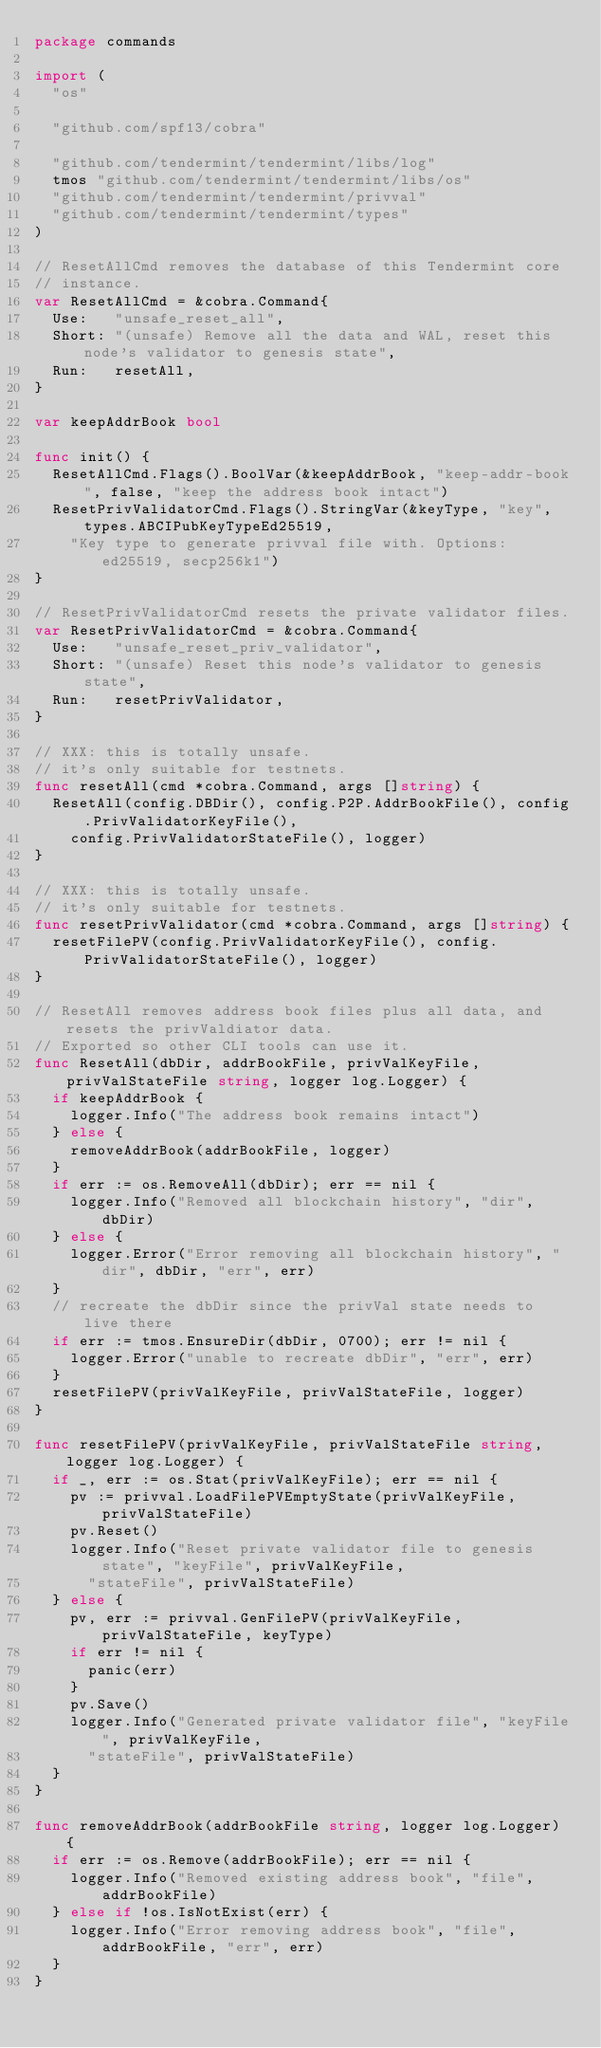Convert code to text. <code><loc_0><loc_0><loc_500><loc_500><_Go_>package commands

import (
	"os"

	"github.com/spf13/cobra"

	"github.com/tendermint/tendermint/libs/log"
	tmos "github.com/tendermint/tendermint/libs/os"
	"github.com/tendermint/tendermint/privval"
	"github.com/tendermint/tendermint/types"
)

// ResetAllCmd removes the database of this Tendermint core
// instance.
var ResetAllCmd = &cobra.Command{
	Use:   "unsafe_reset_all",
	Short: "(unsafe) Remove all the data and WAL, reset this node's validator to genesis state",
	Run:   resetAll,
}

var keepAddrBook bool

func init() {
	ResetAllCmd.Flags().BoolVar(&keepAddrBook, "keep-addr-book", false, "keep the address book intact")
	ResetPrivValidatorCmd.Flags().StringVar(&keyType, "key", types.ABCIPubKeyTypeEd25519,
		"Key type to generate privval file with. Options: ed25519, secp256k1")
}

// ResetPrivValidatorCmd resets the private validator files.
var ResetPrivValidatorCmd = &cobra.Command{
	Use:   "unsafe_reset_priv_validator",
	Short: "(unsafe) Reset this node's validator to genesis state",
	Run:   resetPrivValidator,
}

// XXX: this is totally unsafe.
// it's only suitable for testnets.
func resetAll(cmd *cobra.Command, args []string) {
	ResetAll(config.DBDir(), config.P2P.AddrBookFile(), config.PrivValidatorKeyFile(),
		config.PrivValidatorStateFile(), logger)
}

// XXX: this is totally unsafe.
// it's only suitable for testnets.
func resetPrivValidator(cmd *cobra.Command, args []string) {
	resetFilePV(config.PrivValidatorKeyFile(), config.PrivValidatorStateFile(), logger)
}

// ResetAll removes address book files plus all data, and resets the privValdiator data.
// Exported so other CLI tools can use it.
func ResetAll(dbDir, addrBookFile, privValKeyFile, privValStateFile string, logger log.Logger) {
	if keepAddrBook {
		logger.Info("The address book remains intact")
	} else {
		removeAddrBook(addrBookFile, logger)
	}
	if err := os.RemoveAll(dbDir); err == nil {
		logger.Info("Removed all blockchain history", "dir", dbDir)
	} else {
		logger.Error("Error removing all blockchain history", "dir", dbDir, "err", err)
	}
	// recreate the dbDir since the privVal state needs to live there
	if err := tmos.EnsureDir(dbDir, 0700); err != nil {
		logger.Error("unable to recreate dbDir", "err", err)
	}
	resetFilePV(privValKeyFile, privValStateFile, logger)
}

func resetFilePV(privValKeyFile, privValStateFile string, logger log.Logger) {
	if _, err := os.Stat(privValKeyFile); err == nil {
		pv := privval.LoadFilePVEmptyState(privValKeyFile, privValStateFile)
		pv.Reset()
		logger.Info("Reset private validator file to genesis state", "keyFile", privValKeyFile,
			"stateFile", privValStateFile)
	} else {
		pv, err := privval.GenFilePV(privValKeyFile, privValStateFile, keyType)
		if err != nil {
			panic(err)
		}
		pv.Save()
		logger.Info("Generated private validator file", "keyFile", privValKeyFile,
			"stateFile", privValStateFile)
	}
}

func removeAddrBook(addrBookFile string, logger log.Logger) {
	if err := os.Remove(addrBookFile); err == nil {
		logger.Info("Removed existing address book", "file", addrBookFile)
	} else if !os.IsNotExist(err) {
		logger.Info("Error removing address book", "file", addrBookFile, "err", err)
	}
}
</code> 